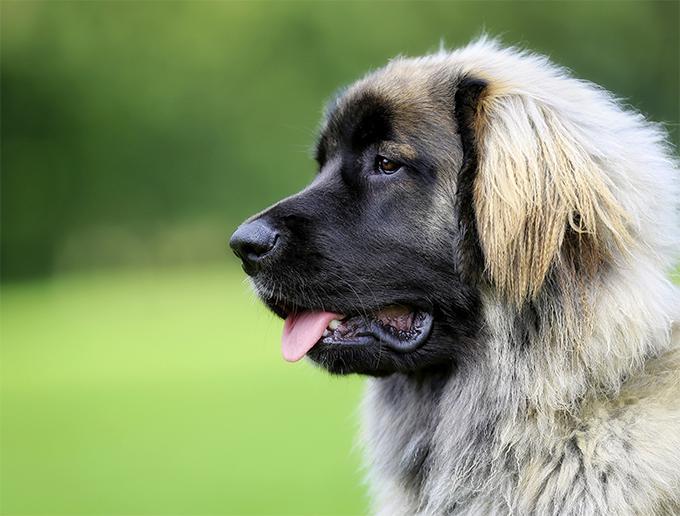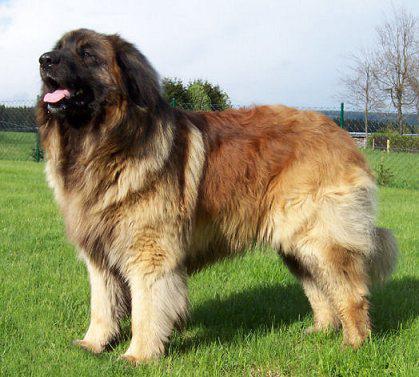The first image is the image on the left, the second image is the image on the right. For the images shown, is this caption "Both images show a single adult dog looking left." true? Answer yes or no. Yes. 